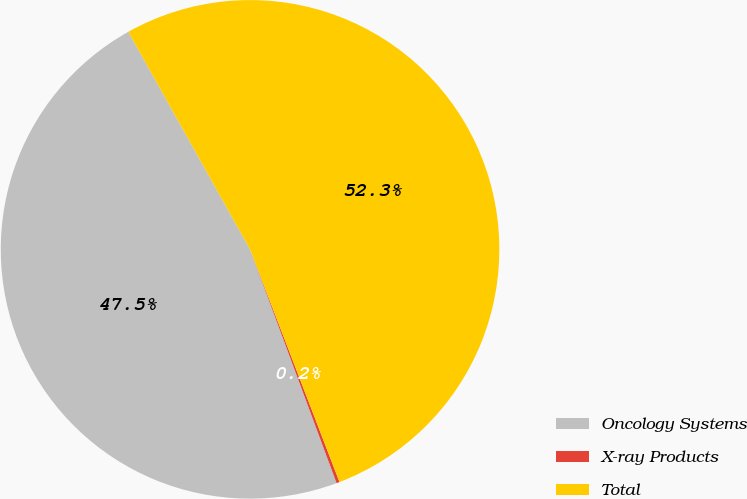Convert chart. <chart><loc_0><loc_0><loc_500><loc_500><pie_chart><fcel>Oncology Systems<fcel>X-ray Products<fcel>Total<nl><fcel>47.53%<fcel>0.2%<fcel>52.28%<nl></chart> 